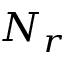<formula> <loc_0><loc_0><loc_500><loc_500>N _ { r }</formula> 